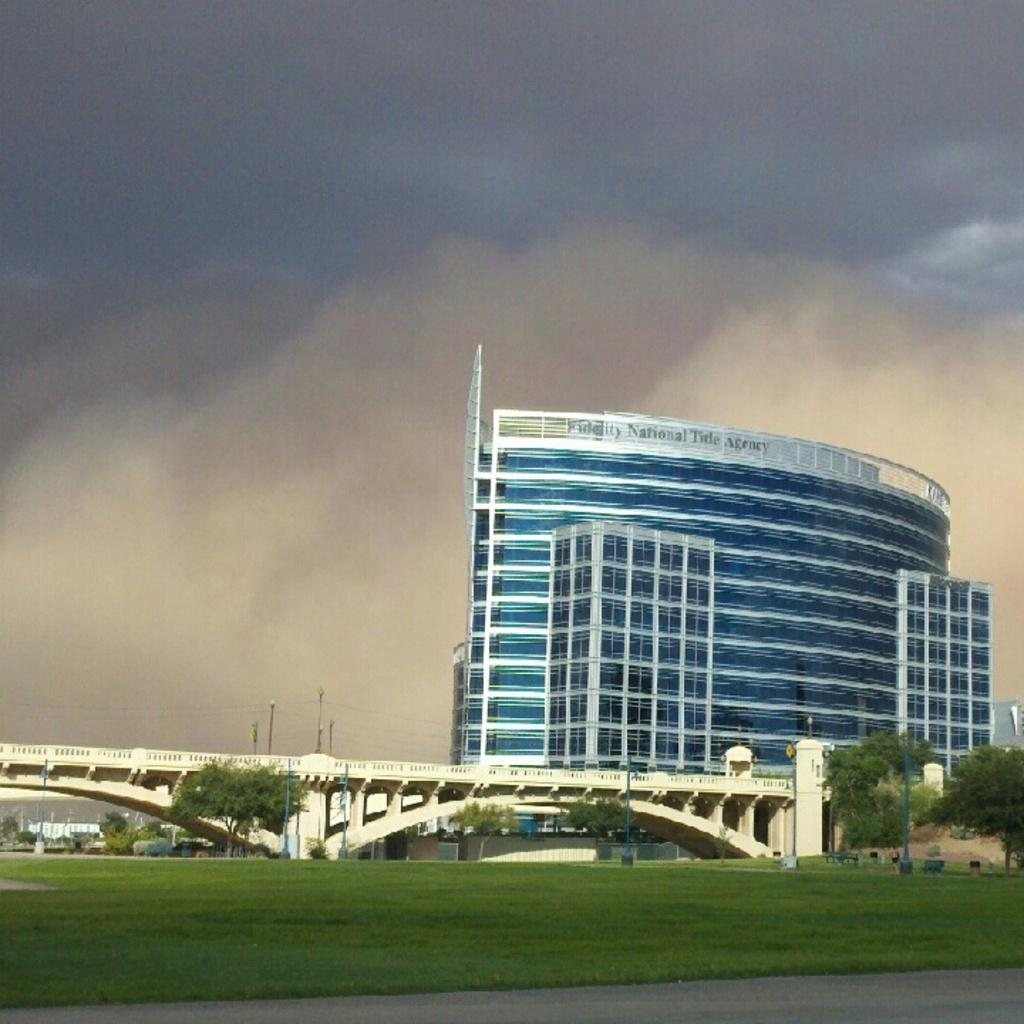What type of terrain is visible in the image? There is a grass lawn in the image. What structures can be seen in the background of the image? There is a bridge, a tree, a building, and the sky visible in the background of the image. What is the condition of the sky in the image? The sky is visible in the background of the image, and clouds are present. How many lizards are sitting on the credit card in the image? There are no lizards or credit cards present in the image. 